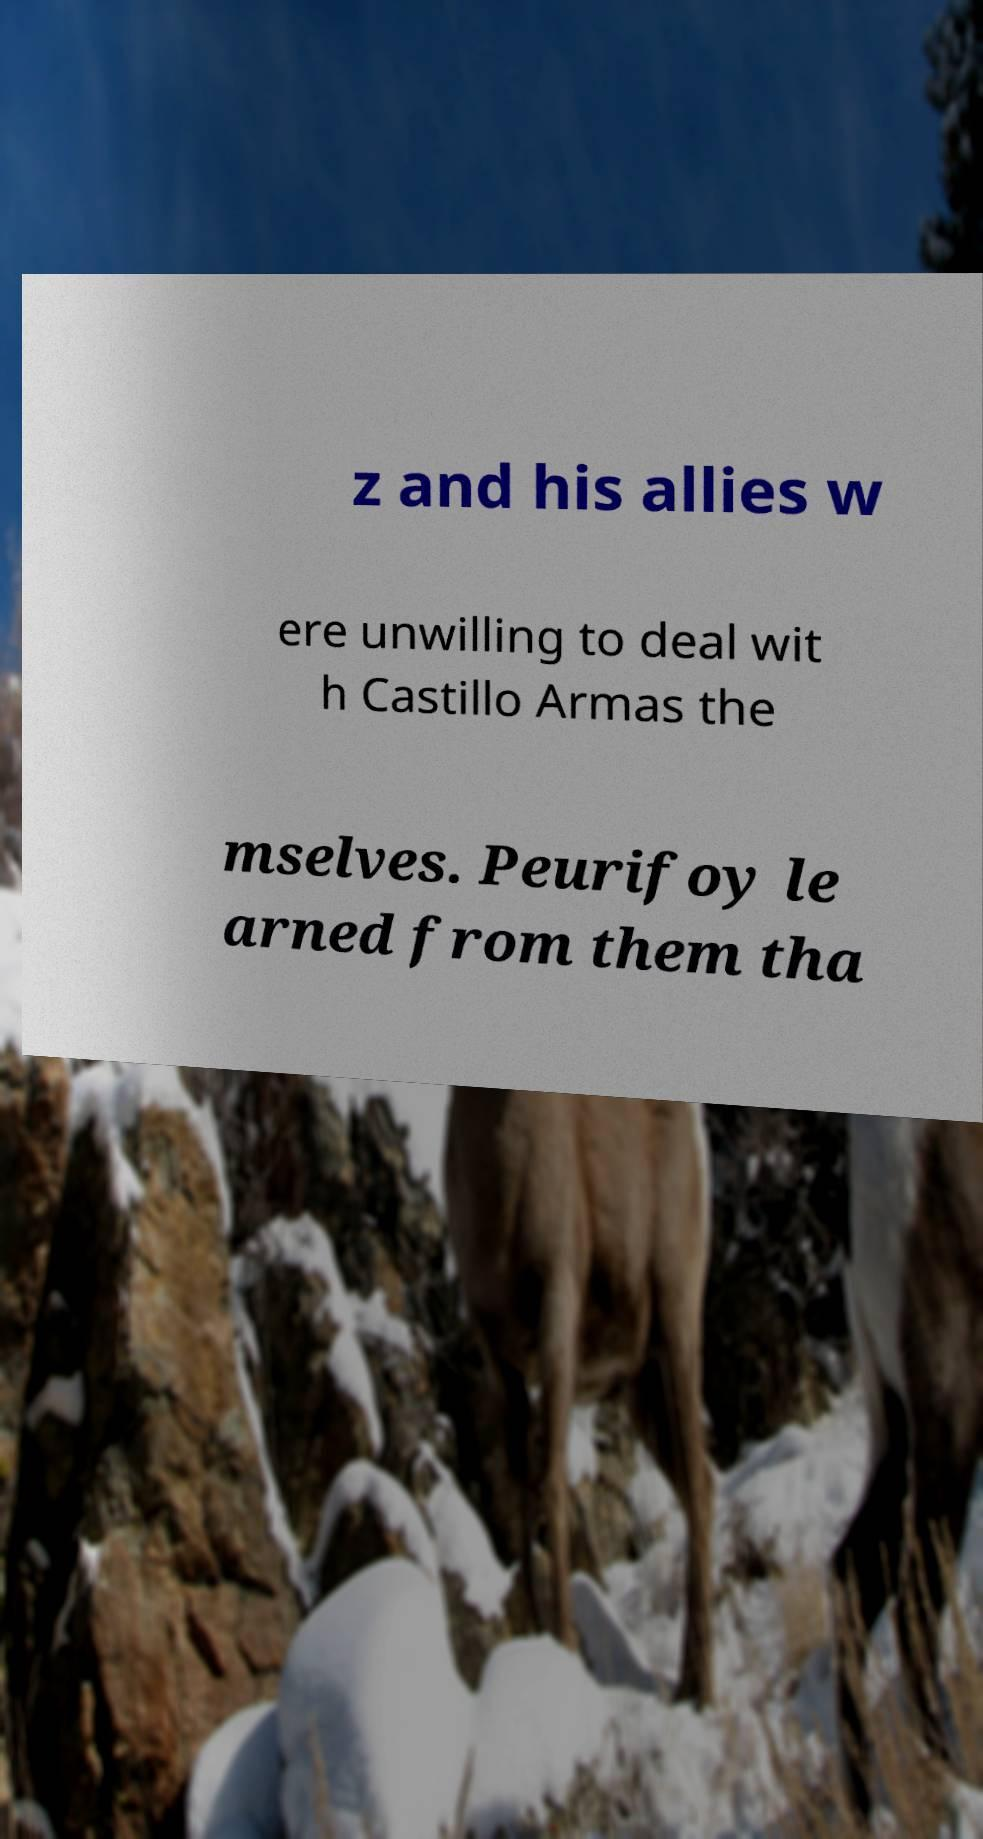I need the written content from this picture converted into text. Can you do that? z and his allies w ere unwilling to deal wit h Castillo Armas the mselves. Peurifoy le arned from them tha 